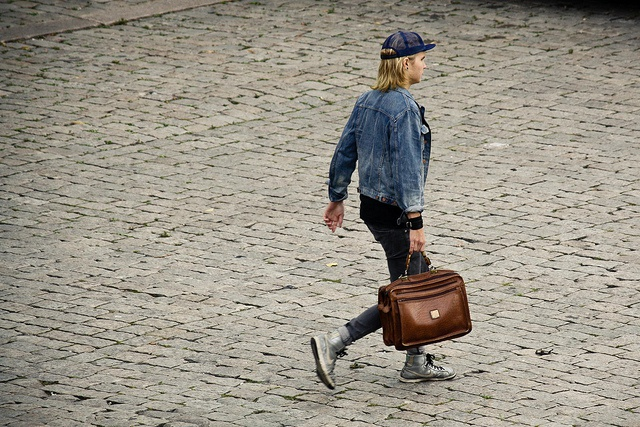Describe the objects in this image and their specific colors. I can see people in black, gray, blue, and maroon tones, handbag in black, maroon, and brown tones, and suitcase in black, maroon, and brown tones in this image. 